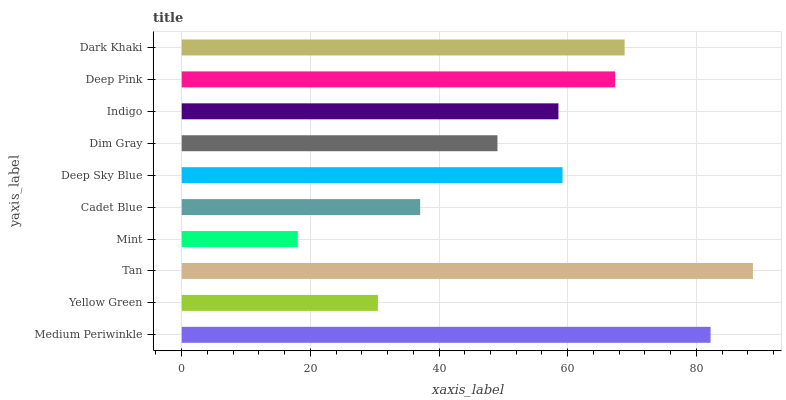Is Mint the minimum?
Answer yes or no. Yes. Is Tan the maximum?
Answer yes or no. Yes. Is Yellow Green the minimum?
Answer yes or no. No. Is Yellow Green the maximum?
Answer yes or no. No. Is Medium Periwinkle greater than Yellow Green?
Answer yes or no. Yes. Is Yellow Green less than Medium Periwinkle?
Answer yes or no. Yes. Is Yellow Green greater than Medium Periwinkle?
Answer yes or no. No. Is Medium Periwinkle less than Yellow Green?
Answer yes or no. No. Is Deep Sky Blue the high median?
Answer yes or no. Yes. Is Indigo the low median?
Answer yes or no. Yes. Is Mint the high median?
Answer yes or no. No. Is Dark Khaki the low median?
Answer yes or no. No. 